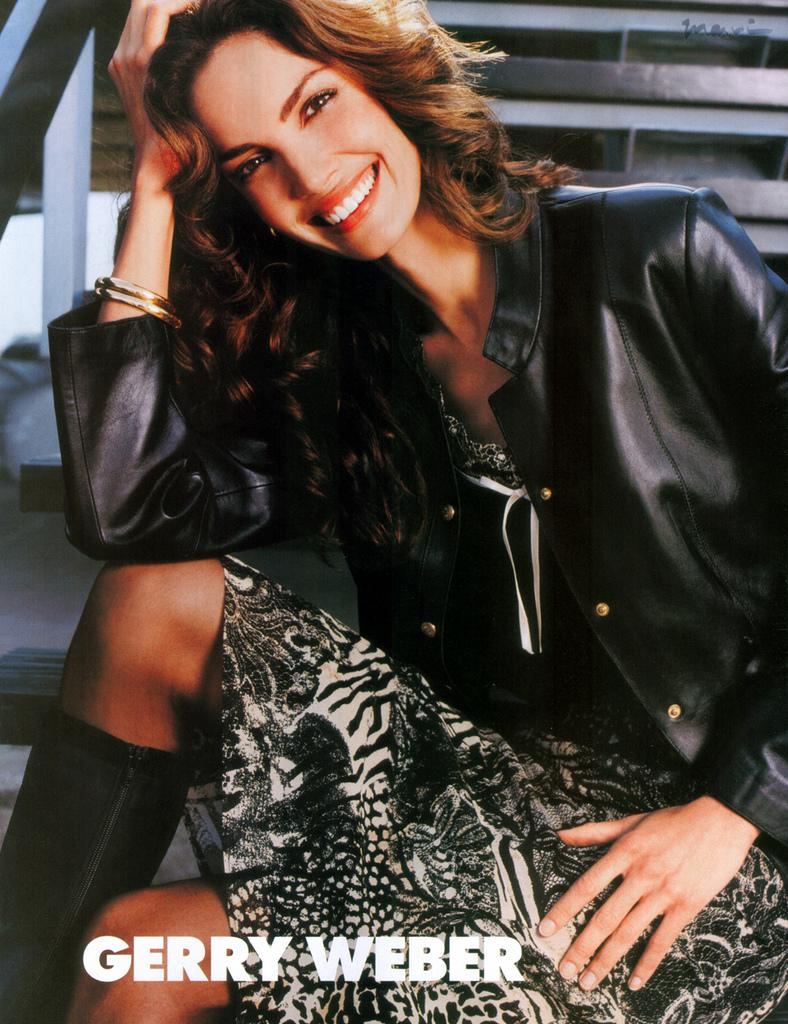What is the main subject of the image? The main subject of the image is a woman. Can you describe any architectural features in the background of the image? Yes, there are stairs in the background of the image. What type of chess piece is the woman holding in the image? There is no chess piece visible in the image. What type of house is the woman standing in front of in the image? There is no house present in the image; it only features a woman and stairs in the background. 